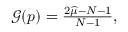Convert formula to latex. <formula><loc_0><loc_0><loc_500><loc_500>\begin{array} { r } { \mathcal { G } ( p ) = \frac { 2 \widehat { \mu } - N - 1 } { N - 1 } , } \end{array}</formula> 